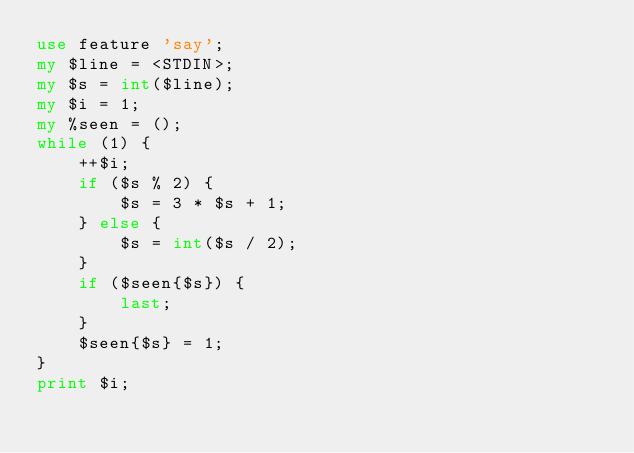Convert code to text. <code><loc_0><loc_0><loc_500><loc_500><_Perl_>use feature 'say';
my $line = <STDIN>;
my $s = int($line);
my $i = 1;
my %seen = ();
while (1) {
	++$i;
    if ($s % 2) {
    	$s = 3 * $s + 1;
    } else {
    	$s = int($s / 2);
    }
    if ($seen{$s}) {
		last;
    }
    $seen{$s} = 1;
}
print $i;</code> 